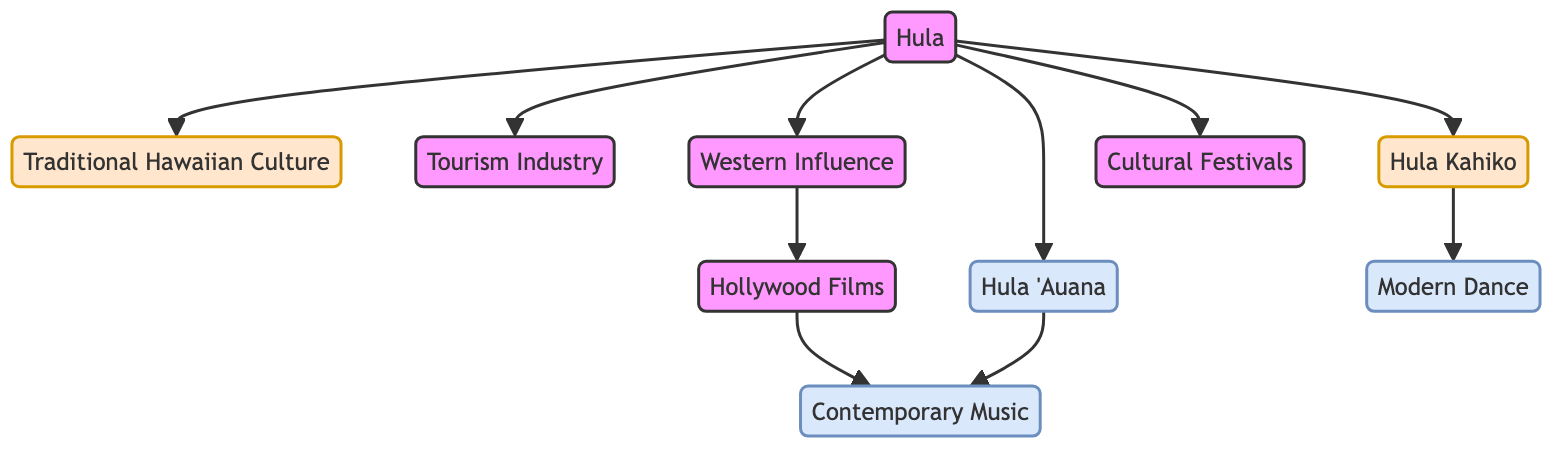what is the total number of nodes in the diagram? To find the total number of nodes, we can count each unique node listed in the data. The nodes are: Hula, Traditional Hawaiian Culture, Tourism Industry, Western Influence, Hollywood Films, Contemporary Music, Hula 'Auana, Hula Kahiko, Modern Dance, and Cultural Festivals. There are 10 nodes in total.
Answer: 10 which node is directly connected to Hula? To determine which nodes are directly connected to Hula, we look at the edges originating from Hula. The nodes connected to Hula are: Traditional Hawaiian Culture, Tourism Industry, Western Influence, Hula Kahiko, Hula 'Auana, and Cultural Festivals.
Answer: Traditional Hawaiian Culture, Tourism Industry, Western Influence, Hula Kahiko, Hula 'Auana, Cultural Festivals what type of influence does Hula have on Contemporary Music? Hula has a direct influence on Contemporary Music through Hula 'Auana, which connects directly to Contemporary Music in the diagram. Thus, the influence is one of connection.
Answer: Direct influence which two nodes are connected by the edge labeled "Western Influence"? The edge labeled "Western Influence" connects the node Western Influence to the node Hollywood Films. This is a direct connection indicating the influence of Western culture on Hollywood.
Answer: Hollywood Films how many edges originate from the node Hula? By counting the directed edges that originate from Hula in the diagram, we can identify that there are six edges going out from this node to Traditional Hawaiian Culture, Tourism Industry, Western Influence, Hula Kahiko, Hula 'Auana, and Cultural Festivals. Therefore, the answer is 6.
Answer: 6 which dance form is influenced by Hula Kahiko? Hula Kahiko connects directly to Modern Dance in the diagram, indicating that Modern Dance is influenced by Hula Kahiko.
Answer: Modern Dance what is the relationship between Hollywood and Contemporary Music? Hollywood is connected to Contemporary Music through a direct edge. This edge indicates that Hollywood, through its cultural productions such as films and music, has an influence on Contemporary Music.
Answer: Direct influence what role does Tourism play in relation to Hula? The diagram indicates that Hula has a direct connection to the Tourism Industry. This connection indicates that Hula contributes to and is a significant aspect of the tourism sector.
Answer: Contributes to Tourism Industry how does Western Influence relate to the development of Contemporary Music? Western Influence connects to Hollywood, which in turn connects to Contemporary Music in the diagram, showing that the influence of Western culture, particularly through Hollywood productions, plays a significant role in shaping Contemporary Music.
Answer: Through Hollywood Influence 